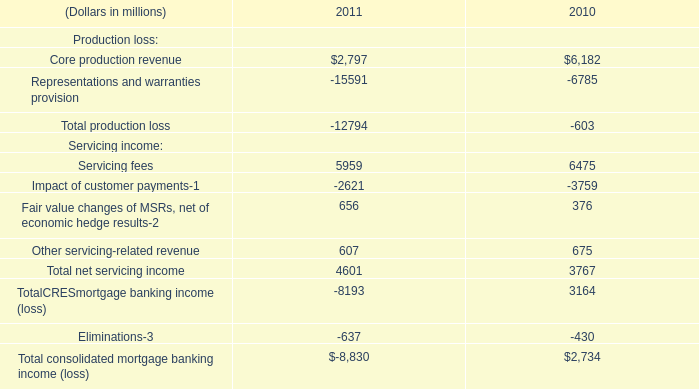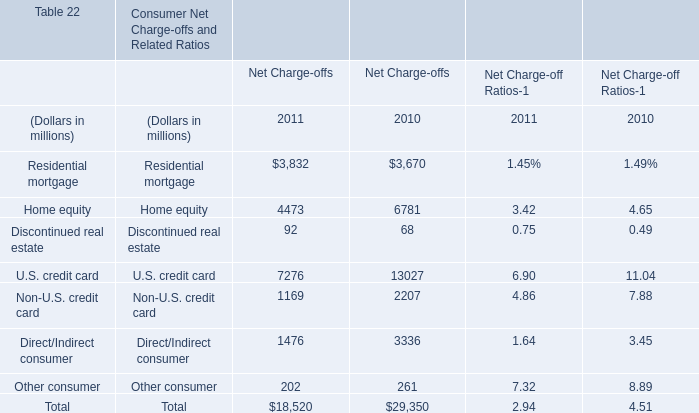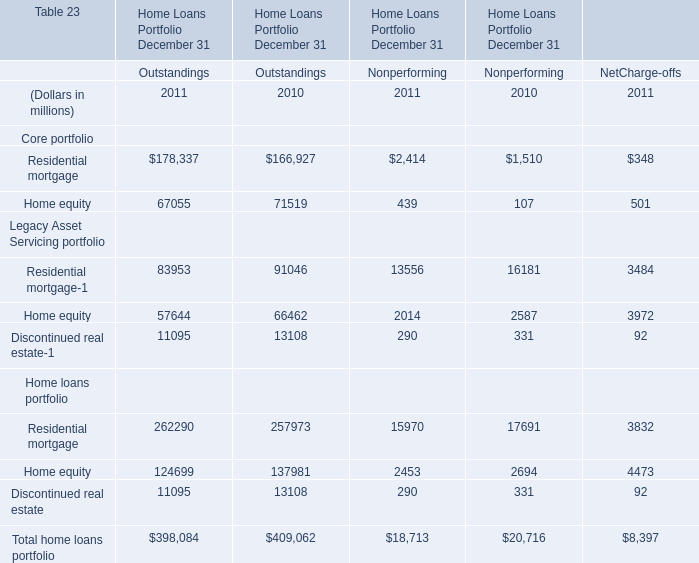In what year is Home equity greater than 1 for Outstandings ? 
Answer: 2011 2010. 